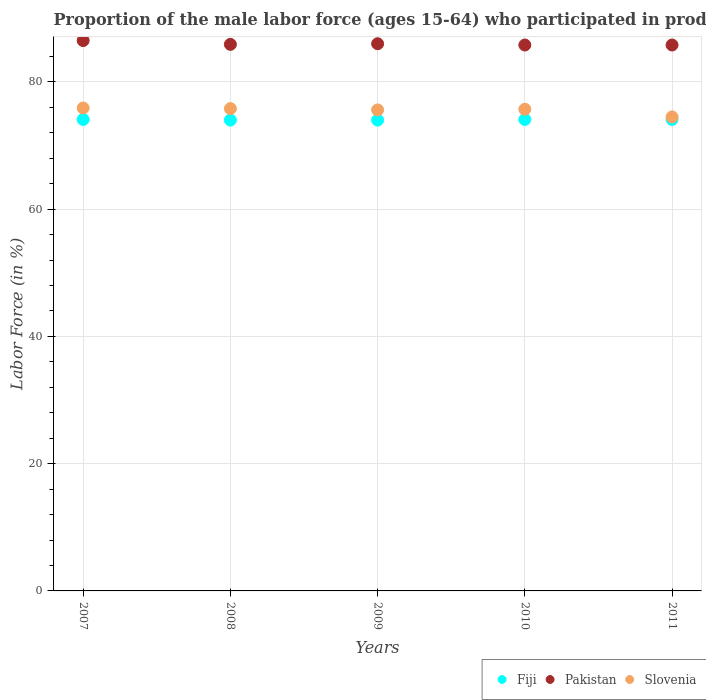How many different coloured dotlines are there?
Keep it short and to the point. 3. Is the number of dotlines equal to the number of legend labels?
Ensure brevity in your answer.  Yes. What is the proportion of the male labor force who participated in production in Fiji in 2007?
Provide a short and direct response. 74.1. Across all years, what is the maximum proportion of the male labor force who participated in production in Pakistan?
Offer a very short reply. 86.5. Across all years, what is the minimum proportion of the male labor force who participated in production in Pakistan?
Ensure brevity in your answer.  85.8. In which year was the proportion of the male labor force who participated in production in Pakistan maximum?
Provide a succinct answer. 2007. In which year was the proportion of the male labor force who participated in production in Slovenia minimum?
Your answer should be very brief. 2011. What is the total proportion of the male labor force who participated in production in Pakistan in the graph?
Make the answer very short. 430. What is the difference between the proportion of the male labor force who participated in production in Slovenia in 2009 and the proportion of the male labor force who participated in production in Pakistan in 2007?
Keep it short and to the point. -10.9. What is the average proportion of the male labor force who participated in production in Pakistan per year?
Make the answer very short. 86. In the year 2008, what is the difference between the proportion of the male labor force who participated in production in Pakistan and proportion of the male labor force who participated in production in Fiji?
Provide a succinct answer. 11.9. In how many years, is the proportion of the male labor force who participated in production in Fiji greater than 40 %?
Ensure brevity in your answer.  5. What is the ratio of the proportion of the male labor force who participated in production in Pakistan in 2010 to that in 2011?
Your response must be concise. 1. Is the difference between the proportion of the male labor force who participated in production in Pakistan in 2010 and 2011 greater than the difference between the proportion of the male labor force who participated in production in Fiji in 2010 and 2011?
Offer a terse response. No. What is the difference between the highest and the second highest proportion of the male labor force who participated in production in Slovenia?
Make the answer very short. 0.1. What is the difference between the highest and the lowest proportion of the male labor force who participated in production in Slovenia?
Keep it short and to the point. 1.4. In how many years, is the proportion of the male labor force who participated in production in Pakistan greater than the average proportion of the male labor force who participated in production in Pakistan taken over all years?
Provide a succinct answer. 1. Is it the case that in every year, the sum of the proportion of the male labor force who participated in production in Fiji and proportion of the male labor force who participated in production in Pakistan  is greater than the proportion of the male labor force who participated in production in Slovenia?
Make the answer very short. Yes. Is the proportion of the male labor force who participated in production in Slovenia strictly greater than the proportion of the male labor force who participated in production in Fiji over the years?
Provide a short and direct response. Yes. What is the difference between two consecutive major ticks on the Y-axis?
Give a very brief answer. 20. Does the graph contain grids?
Your answer should be very brief. Yes. How many legend labels are there?
Make the answer very short. 3. How are the legend labels stacked?
Your answer should be very brief. Horizontal. What is the title of the graph?
Offer a very short reply. Proportion of the male labor force (ages 15-64) who participated in production. What is the Labor Force (in %) in Fiji in 2007?
Your answer should be very brief. 74.1. What is the Labor Force (in %) in Pakistan in 2007?
Make the answer very short. 86.5. What is the Labor Force (in %) in Slovenia in 2007?
Your answer should be compact. 75.9. What is the Labor Force (in %) of Fiji in 2008?
Offer a terse response. 74. What is the Labor Force (in %) of Pakistan in 2008?
Offer a terse response. 85.9. What is the Labor Force (in %) of Slovenia in 2008?
Keep it short and to the point. 75.8. What is the Labor Force (in %) of Pakistan in 2009?
Your answer should be compact. 86. What is the Labor Force (in %) in Slovenia in 2009?
Give a very brief answer. 75.6. What is the Labor Force (in %) of Fiji in 2010?
Offer a very short reply. 74.1. What is the Labor Force (in %) of Pakistan in 2010?
Ensure brevity in your answer.  85.8. What is the Labor Force (in %) of Slovenia in 2010?
Ensure brevity in your answer.  75.7. What is the Labor Force (in %) in Fiji in 2011?
Offer a terse response. 74.1. What is the Labor Force (in %) of Pakistan in 2011?
Provide a succinct answer. 85.8. What is the Labor Force (in %) in Slovenia in 2011?
Give a very brief answer. 74.5. Across all years, what is the maximum Labor Force (in %) in Fiji?
Your answer should be compact. 74.1. Across all years, what is the maximum Labor Force (in %) of Pakistan?
Offer a terse response. 86.5. Across all years, what is the maximum Labor Force (in %) in Slovenia?
Provide a short and direct response. 75.9. Across all years, what is the minimum Labor Force (in %) of Pakistan?
Offer a terse response. 85.8. Across all years, what is the minimum Labor Force (in %) in Slovenia?
Give a very brief answer. 74.5. What is the total Labor Force (in %) in Fiji in the graph?
Give a very brief answer. 370.3. What is the total Labor Force (in %) in Pakistan in the graph?
Ensure brevity in your answer.  430. What is the total Labor Force (in %) in Slovenia in the graph?
Keep it short and to the point. 377.5. What is the difference between the Labor Force (in %) of Pakistan in 2007 and that in 2008?
Keep it short and to the point. 0.6. What is the difference between the Labor Force (in %) of Slovenia in 2007 and that in 2008?
Your answer should be compact. 0.1. What is the difference between the Labor Force (in %) in Fiji in 2007 and that in 2009?
Your answer should be very brief. 0.1. What is the difference between the Labor Force (in %) of Pakistan in 2007 and that in 2009?
Provide a succinct answer. 0.5. What is the difference between the Labor Force (in %) in Slovenia in 2007 and that in 2009?
Your answer should be very brief. 0.3. What is the difference between the Labor Force (in %) in Fiji in 2007 and that in 2010?
Give a very brief answer. 0. What is the difference between the Labor Force (in %) in Slovenia in 2007 and that in 2010?
Offer a terse response. 0.2. What is the difference between the Labor Force (in %) of Slovenia in 2007 and that in 2011?
Offer a terse response. 1.4. What is the difference between the Labor Force (in %) of Fiji in 2008 and that in 2009?
Provide a short and direct response. 0. What is the difference between the Labor Force (in %) of Slovenia in 2008 and that in 2009?
Keep it short and to the point. 0.2. What is the difference between the Labor Force (in %) of Fiji in 2008 and that in 2010?
Your response must be concise. -0.1. What is the difference between the Labor Force (in %) of Pakistan in 2008 and that in 2010?
Provide a short and direct response. 0.1. What is the difference between the Labor Force (in %) in Slovenia in 2008 and that in 2010?
Offer a very short reply. 0.1. What is the difference between the Labor Force (in %) of Slovenia in 2008 and that in 2011?
Provide a succinct answer. 1.3. What is the difference between the Labor Force (in %) in Fiji in 2009 and that in 2011?
Provide a succinct answer. -0.1. What is the difference between the Labor Force (in %) in Pakistan in 2009 and that in 2011?
Give a very brief answer. 0.2. What is the difference between the Labor Force (in %) of Slovenia in 2009 and that in 2011?
Provide a succinct answer. 1.1. What is the difference between the Labor Force (in %) in Fiji in 2007 and the Labor Force (in %) in Slovenia in 2008?
Offer a very short reply. -1.7. What is the difference between the Labor Force (in %) in Fiji in 2007 and the Labor Force (in %) in Pakistan in 2010?
Give a very brief answer. -11.7. What is the difference between the Labor Force (in %) in Pakistan in 2007 and the Labor Force (in %) in Slovenia in 2010?
Offer a very short reply. 10.8. What is the difference between the Labor Force (in %) of Fiji in 2007 and the Labor Force (in %) of Slovenia in 2011?
Offer a terse response. -0.4. What is the difference between the Labor Force (in %) in Fiji in 2008 and the Labor Force (in %) in Pakistan in 2010?
Make the answer very short. -11.8. What is the difference between the Labor Force (in %) in Fiji in 2008 and the Labor Force (in %) in Slovenia in 2010?
Keep it short and to the point. -1.7. What is the difference between the Labor Force (in %) in Pakistan in 2008 and the Labor Force (in %) in Slovenia in 2011?
Provide a short and direct response. 11.4. What is the difference between the Labor Force (in %) of Fiji in 2009 and the Labor Force (in %) of Pakistan in 2011?
Offer a terse response. -11.8. What is the difference between the Labor Force (in %) in Pakistan in 2009 and the Labor Force (in %) in Slovenia in 2011?
Your answer should be compact. 11.5. What is the difference between the Labor Force (in %) of Fiji in 2010 and the Labor Force (in %) of Pakistan in 2011?
Make the answer very short. -11.7. What is the difference between the Labor Force (in %) of Pakistan in 2010 and the Labor Force (in %) of Slovenia in 2011?
Ensure brevity in your answer.  11.3. What is the average Labor Force (in %) in Fiji per year?
Offer a terse response. 74.06. What is the average Labor Force (in %) of Pakistan per year?
Your answer should be very brief. 86. What is the average Labor Force (in %) in Slovenia per year?
Ensure brevity in your answer.  75.5. In the year 2007, what is the difference between the Labor Force (in %) in Fiji and Labor Force (in %) in Pakistan?
Your answer should be compact. -12.4. In the year 2007, what is the difference between the Labor Force (in %) of Fiji and Labor Force (in %) of Slovenia?
Your answer should be very brief. -1.8. In the year 2008, what is the difference between the Labor Force (in %) in Fiji and Labor Force (in %) in Slovenia?
Ensure brevity in your answer.  -1.8. In the year 2008, what is the difference between the Labor Force (in %) in Pakistan and Labor Force (in %) in Slovenia?
Provide a succinct answer. 10.1. In the year 2009, what is the difference between the Labor Force (in %) of Pakistan and Labor Force (in %) of Slovenia?
Offer a terse response. 10.4. In the year 2011, what is the difference between the Labor Force (in %) in Fiji and Labor Force (in %) in Pakistan?
Offer a very short reply. -11.7. In the year 2011, what is the difference between the Labor Force (in %) of Fiji and Labor Force (in %) of Slovenia?
Provide a succinct answer. -0.4. In the year 2011, what is the difference between the Labor Force (in %) in Pakistan and Labor Force (in %) in Slovenia?
Your answer should be very brief. 11.3. What is the ratio of the Labor Force (in %) of Fiji in 2007 to that in 2008?
Provide a short and direct response. 1. What is the ratio of the Labor Force (in %) in Pakistan in 2007 to that in 2008?
Provide a short and direct response. 1.01. What is the ratio of the Labor Force (in %) in Slovenia in 2007 to that in 2008?
Your answer should be very brief. 1. What is the ratio of the Labor Force (in %) of Pakistan in 2007 to that in 2009?
Ensure brevity in your answer.  1.01. What is the ratio of the Labor Force (in %) of Slovenia in 2007 to that in 2009?
Keep it short and to the point. 1. What is the ratio of the Labor Force (in %) of Pakistan in 2007 to that in 2010?
Provide a short and direct response. 1.01. What is the ratio of the Labor Force (in %) in Pakistan in 2007 to that in 2011?
Your answer should be very brief. 1.01. What is the ratio of the Labor Force (in %) in Slovenia in 2007 to that in 2011?
Give a very brief answer. 1.02. What is the ratio of the Labor Force (in %) of Slovenia in 2008 to that in 2009?
Ensure brevity in your answer.  1. What is the ratio of the Labor Force (in %) in Slovenia in 2008 to that in 2010?
Your response must be concise. 1. What is the ratio of the Labor Force (in %) in Fiji in 2008 to that in 2011?
Offer a terse response. 1. What is the ratio of the Labor Force (in %) in Slovenia in 2008 to that in 2011?
Ensure brevity in your answer.  1.02. What is the ratio of the Labor Force (in %) in Fiji in 2009 to that in 2010?
Offer a very short reply. 1. What is the ratio of the Labor Force (in %) in Pakistan in 2009 to that in 2010?
Provide a succinct answer. 1. What is the ratio of the Labor Force (in %) in Slovenia in 2009 to that in 2011?
Provide a short and direct response. 1.01. What is the ratio of the Labor Force (in %) in Slovenia in 2010 to that in 2011?
Give a very brief answer. 1.02. What is the difference between the highest and the lowest Labor Force (in %) of Slovenia?
Keep it short and to the point. 1.4. 